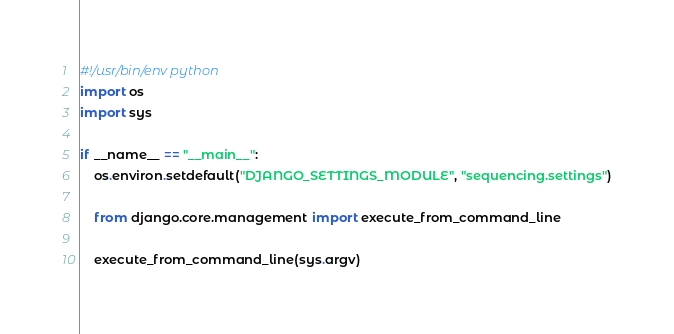Convert code to text. <code><loc_0><loc_0><loc_500><loc_500><_Python_>#!/usr/bin/env python
import os
import sys

if __name__ == "__main__":
    os.environ.setdefault("DJANGO_SETTINGS_MODULE", "sequencing.settings")

    from django.core.management import execute_from_command_line

    execute_from_command_line(sys.argv)
</code> 